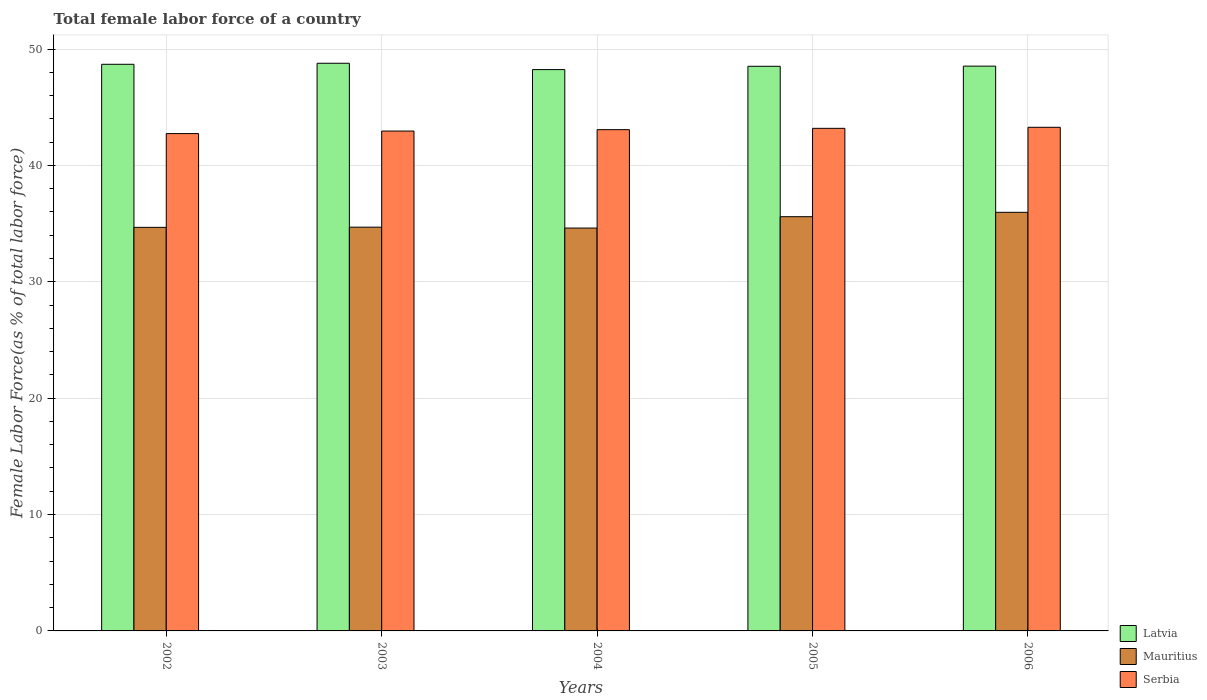How many groups of bars are there?
Make the answer very short. 5. Are the number of bars per tick equal to the number of legend labels?
Your response must be concise. Yes. Are the number of bars on each tick of the X-axis equal?
Make the answer very short. Yes. How many bars are there on the 5th tick from the left?
Give a very brief answer. 3. What is the label of the 3rd group of bars from the left?
Your answer should be very brief. 2004. What is the percentage of female labor force in Latvia in 2003?
Your answer should be compact. 48.78. Across all years, what is the maximum percentage of female labor force in Latvia?
Ensure brevity in your answer.  48.78. Across all years, what is the minimum percentage of female labor force in Latvia?
Offer a terse response. 48.23. In which year was the percentage of female labor force in Serbia maximum?
Make the answer very short. 2006. In which year was the percentage of female labor force in Serbia minimum?
Ensure brevity in your answer.  2002. What is the total percentage of female labor force in Mauritius in the graph?
Provide a short and direct response. 175.54. What is the difference between the percentage of female labor force in Serbia in 2003 and that in 2004?
Ensure brevity in your answer.  -0.12. What is the difference between the percentage of female labor force in Mauritius in 2005 and the percentage of female labor force in Serbia in 2006?
Provide a succinct answer. -7.68. What is the average percentage of female labor force in Mauritius per year?
Keep it short and to the point. 35.11. In the year 2002, what is the difference between the percentage of female labor force in Latvia and percentage of female labor force in Serbia?
Keep it short and to the point. 5.95. In how many years, is the percentage of female labor force in Latvia greater than 42 %?
Your answer should be very brief. 5. What is the ratio of the percentage of female labor force in Mauritius in 2003 to that in 2005?
Offer a very short reply. 0.97. Is the percentage of female labor force in Latvia in 2002 less than that in 2003?
Make the answer very short. Yes. What is the difference between the highest and the second highest percentage of female labor force in Mauritius?
Your response must be concise. 0.38. What is the difference between the highest and the lowest percentage of female labor force in Serbia?
Make the answer very short. 0.54. What does the 2nd bar from the left in 2005 represents?
Your response must be concise. Mauritius. What does the 2nd bar from the right in 2003 represents?
Make the answer very short. Mauritius. Are all the bars in the graph horizontal?
Provide a short and direct response. No. What is the difference between two consecutive major ticks on the Y-axis?
Your answer should be compact. 10. Does the graph contain any zero values?
Offer a terse response. No. How are the legend labels stacked?
Your response must be concise. Vertical. What is the title of the graph?
Ensure brevity in your answer.  Total female labor force of a country. Does "Romania" appear as one of the legend labels in the graph?
Ensure brevity in your answer.  No. What is the label or title of the X-axis?
Your answer should be very brief. Years. What is the label or title of the Y-axis?
Your response must be concise. Female Labor Force(as % of total labor force). What is the Female Labor Force(as % of total labor force) in Latvia in 2002?
Give a very brief answer. 48.69. What is the Female Labor Force(as % of total labor force) in Mauritius in 2002?
Give a very brief answer. 34.68. What is the Female Labor Force(as % of total labor force) of Serbia in 2002?
Ensure brevity in your answer.  42.73. What is the Female Labor Force(as % of total labor force) in Latvia in 2003?
Your answer should be very brief. 48.78. What is the Female Labor Force(as % of total labor force) of Mauritius in 2003?
Make the answer very short. 34.69. What is the Female Labor Force(as % of total labor force) of Serbia in 2003?
Your answer should be compact. 42.95. What is the Female Labor Force(as % of total labor force) in Latvia in 2004?
Keep it short and to the point. 48.23. What is the Female Labor Force(as % of total labor force) of Mauritius in 2004?
Make the answer very short. 34.62. What is the Female Labor Force(as % of total labor force) in Serbia in 2004?
Your answer should be very brief. 43.07. What is the Female Labor Force(as % of total labor force) of Latvia in 2005?
Your answer should be compact. 48.52. What is the Female Labor Force(as % of total labor force) of Mauritius in 2005?
Offer a very short reply. 35.59. What is the Female Labor Force(as % of total labor force) in Serbia in 2005?
Your answer should be very brief. 43.18. What is the Female Labor Force(as % of total labor force) in Latvia in 2006?
Your response must be concise. 48.53. What is the Female Labor Force(as % of total labor force) of Mauritius in 2006?
Ensure brevity in your answer.  35.97. What is the Female Labor Force(as % of total labor force) in Serbia in 2006?
Ensure brevity in your answer.  43.27. Across all years, what is the maximum Female Labor Force(as % of total labor force) in Latvia?
Ensure brevity in your answer.  48.78. Across all years, what is the maximum Female Labor Force(as % of total labor force) in Mauritius?
Provide a short and direct response. 35.97. Across all years, what is the maximum Female Labor Force(as % of total labor force) of Serbia?
Your answer should be very brief. 43.27. Across all years, what is the minimum Female Labor Force(as % of total labor force) of Latvia?
Your answer should be compact. 48.23. Across all years, what is the minimum Female Labor Force(as % of total labor force) of Mauritius?
Make the answer very short. 34.62. Across all years, what is the minimum Female Labor Force(as % of total labor force) in Serbia?
Give a very brief answer. 42.73. What is the total Female Labor Force(as % of total labor force) of Latvia in the graph?
Offer a terse response. 242.74. What is the total Female Labor Force(as % of total labor force) in Mauritius in the graph?
Your response must be concise. 175.54. What is the total Female Labor Force(as % of total labor force) of Serbia in the graph?
Your answer should be very brief. 215.21. What is the difference between the Female Labor Force(as % of total labor force) in Latvia in 2002 and that in 2003?
Offer a very short reply. -0.09. What is the difference between the Female Labor Force(as % of total labor force) in Mauritius in 2002 and that in 2003?
Give a very brief answer. -0.02. What is the difference between the Female Labor Force(as % of total labor force) in Serbia in 2002 and that in 2003?
Offer a very short reply. -0.22. What is the difference between the Female Labor Force(as % of total labor force) of Latvia in 2002 and that in 2004?
Provide a succinct answer. 0.46. What is the difference between the Female Labor Force(as % of total labor force) of Mauritius in 2002 and that in 2004?
Offer a terse response. 0.06. What is the difference between the Female Labor Force(as % of total labor force) of Serbia in 2002 and that in 2004?
Offer a terse response. -0.34. What is the difference between the Female Labor Force(as % of total labor force) of Latvia in 2002 and that in 2005?
Your answer should be compact. 0.17. What is the difference between the Female Labor Force(as % of total labor force) of Mauritius in 2002 and that in 2005?
Make the answer very short. -0.92. What is the difference between the Female Labor Force(as % of total labor force) in Serbia in 2002 and that in 2005?
Ensure brevity in your answer.  -0.45. What is the difference between the Female Labor Force(as % of total labor force) in Latvia in 2002 and that in 2006?
Offer a very short reply. 0.16. What is the difference between the Female Labor Force(as % of total labor force) of Mauritius in 2002 and that in 2006?
Give a very brief answer. -1.29. What is the difference between the Female Labor Force(as % of total labor force) of Serbia in 2002 and that in 2006?
Your response must be concise. -0.54. What is the difference between the Female Labor Force(as % of total labor force) in Latvia in 2003 and that in 2004?
Your answer should be compact. 0.55. What is the difference between the Female Labor Force(as % of total labor force) in Mauritius in 2003 and that in 2004?
Give a very brief answer. 0.08. What is the difference between the Female Labor Force(as % of total labor force) of Serbia in 2003 and that in 2004?
Provide a short and direct response. -0.12. What is the difference between the Female Labor Force(as % of total labor force) in Latvia in 2003 and that in 2005?
Provide a succinct answer. 0.26. What is the difference between the Female Labor Force(as % of total labor force) of Mauritius in 2003 and that in 2005?
Offer a very short reply. -0.9. What is the difference between the Female Labor Force(as % of total labor force) in Serbia in 2003 and that in 2005?
Offer a very short reply. -0.23. What is the difference between the Female Labor Force(as % of total labor force) in Latvia in 2003 and that in 2006?
Your answer should be very brief. 0.25. What is the difference between the Female Labor Force(as % of total labor force) in Mauritius in 2003 and that in 2006?
Your response must be concise. -1.28. What is the difference between the Female Labor Force(as % of total labor force) in Serbia in 2003 and that in 2006?
Give a very brief answer. -0.32. What is the difference between the Female Labor Force(as % of total labor force) of Latvia in 2004 and that in 2005?
Provide a short and direct response. -0.28. What is the difference between the Female Labor Force(as % of total labor force) in Mauritius in 2004 and that in 2005?
Your answer should be compact. -0.98. What is the difference between the Female Labor Force(as % of total labor force) in Serbia in 2004 and that in 2005?
Your answer should be very brief. -0.11. What is the difference between the Female Labor Force(as % of total labor force) of Latvia in 2004 and that in 2006?
Give a very brief answer. -0.3. What is the difference between the Female Labor Force(as % of total labor force) of Mauritius in 2004 and that in 2006?
Your answer should be very brief. -1.35. What is the difference between the Female Labor Force(as % of total labor force) of Serbia in 2004 and that in 2006?
Offer a terse response. -0.2. What is the difference between the Female Labor Force(as % of total labor force) of Latvia in 2005 and that in 2006?
Offer a very short reply. -0.01. What is the difference between the Female Labor Force(as % of total labor force) of Mauritius in 2005 and that in 2006?
Offer a terse response. -0.38. What is the difference between the Female Labor Force(as % of total labor force) of Serbia in 2005 and that in 2006?
Provide a succinct answer. -0.09. What is the difference between the Female Labor Force(as % of total labor force) in Latvia in 2002 and the Female Labor Force(as % of total labor force) in Mauritius in 2003?
Offer a terse response. 14. What is the difference between the Female Labor Force(as % of total labor force) of Latvia in 2002 and the Female Labor Force(as % of total labor force) of Serbia in 2003?
Offer a very short reply. 5.74. What is the difference between the Female Labor Force(as % of total labor force) in Mauritius in 2002 and the Female Labor Force(as % of total labor force) in Serbia in 2003?
Ensure brevity in your answer.  -8.28. What is the difference between the Female Labor Force(as % of total labor force) in Latvia in 2002 and the Female Labor Force(as % of total labor force) in Mauritius in 2004?
Provide a short and direct response. 14.07. What is the difference between the Female Labor Force(as % of total labor force) in Latvia in 2002 and the Female Labor Force(as % of total labor force) in Serbia in 2004?
Offer a terse response. 5.62. What is the difference between the Female Labor Force(as % of total labor force) of Mauritius in 2002 and the Female Labor Force(as % of total labor force) of Serbia in 2004?
Your answer should be compact. -8.39. What is the difference between the Female Labor Force(as % of total labor force) of Latvia in 2002 and the Female Labor Force(as % of total labor force) of Mauritius in 2005?
Offer a very short reply. 13.1. What is the difference between the Female Labor Force(as % of total labor force) in Latvia in 2002 and the Female Labor Force(as % of total labor force) in Serbia in 2005?
Your answer should be very brief. 5.5. What is the difference between the Female Labor Force(as % of total labor force) in Mauritius in 2002 and the Female Labor Force(as % of total labor force) in Serbia in 2005?
Your answer should be very brief. -8.51. What is the difference between the Female Labor Force(as % of total labor force) in Latvia in 2002 and the Female Labor Force(as % of total labor force) in Mauritius in 2006?
Provide a short and direct response. 12.72. What is the difference between the Female Labor Force(as % of total labor force) in Latvia in 2002 and the Female Labor Force(as % of total labor force) in Serbia in 2006?
Keep it short and to the point. 5.41. What is the difference between the Female Labor Force(as % of total labor force) in Mauritius in 2002 and the Female Labor Force(as % of total labor force) in Serbia in 2006?
Ensure brevity in your answer.  -8.6. What is the difference between the Female Labor Force(as % of total labor force) in Latvia in 2003 and the Female Labor Force(as % of total labor force) in Mauritius in 2004?
Offer a terse response. 14.16. What is the difference between the Female Labor Force(as % of total labor force) in Latvia in 2003 and the Female Labor Force(as % of total labor force) in Serbia in 2004?
Keep it short and to the point. 5.71. What is the difference between the Female Labor Force(as % of total labor force) of Mauritius in 2003 and the Female Labor Force(as % of total labor force) of Serbia in 2004?
Offer a terse response. -8.38. What is the difference between the Female Labor Force(as % of total labor force) in Latvia in 2003 and the Female Labor Force(as % of total labor force) in Mauritius in 2005?
Make the answer very short. 13.18. What is the difference between the Female Labor Force(as % of total labor force) of Latvia in 2003 and the Female Labor Force(as % of total labor force) of Serbia in 2005?
Provide a succinct answer. 5.59. What is the difference between the Female Labor Force(as % of total labor force) of Mauritius in 2003 and the Female Labor Force(as % of total labor force) of Serbia in 2005?
Give a very brief answer. -8.49. What is the difference between the Female Labor Force(as % of total labor force) of Latvia in 2003 and the Female Labor Force(as % of total labor force) of Mauritius in 2006?
Provide a succinct answer. 12.81. What is the difference between the Female Labor Force(as % of total labor force) of Latvia in 2003 and the Female Labor Force(as % of total labor force) of Serbia in 2006?
Provide a short and direct response. 5.5. What is the difference between the Female Labor Force(as % of total labor force) in Mauritius in 2003 and the Female Labor Force(as % of total labor force) in Serbia in 2006?
Provide a short and direct response. -8.58. What is the difference between the Female Labor Force(as % of total labor force) of Latvia in 2004 and the Female Labor Force(as % of total labor force) of Mauritius in 2005?
Ensure brevity in your answer.  12.64. What is the difference between the Female Labor Force(as % of total labor force) of Latvia in 2004 and the Female Labor Force(as % of total labor force) of Serbia in 2005?
Offer a very short reply. 5.05. What is the difference between the Female Labor Force(as % of total labor force) of Mauritius in 2004 and the Female Labor Force(as % of total labor force) of Serbia in 2005?
Offer a terse response. -8.57. What is the difference between the Female Labor Force(as % of total labor force) of Latvia in 2004 and the Female Labor Force(as % of total labor force) of Mauritius in 2006?
Provide a short and direct response. 12.26. What is the difference between the Female Labor Force(as % of total labor force) in Latvia in 2004 and the Female Labor Force(as % of total labor force) in Serbia in 2006?
Make the answer very short. 4.96. What is the difference between the Female Labor Force(as % of total labor force) in Mauritius in 2004 and the Female Labor Force(as % of total labor force) in Serbia in 2006?
Ensure brevity in your answer.  -8.66. What is the difference between the Female Labor Force(as % of total labor force) of Latvia in 2005 and the Female Labor Force(as % of total labor force) of Mauritius in 2006?
Your response must be concise. 12.55. What is the difference between the Female Labor Force(as % of total labor force) of Latvia in 2005 and the Female Labor Force(as % of total labor force) of Serbia in 2006?
Keep it short and to the point. 5.24. What is the difference between the Female Labor Force(as % of total labor force) in Mauritius in 2005 and the Female Labor Force(as % of total labor force) in Serbia in 2006?
Your answer should be compact. -7.68. What is the average Female Labor Force(as % of total labor force) in Latvia per year?
Give a very brief answer. 48.55. What is the average Female Labor Force(as % of total labor force) in Mauritius per year?
Your answer should be compact. 35.11. What is the average Female Labor Force(as % of total labor force) in Serbia per year?
Ensure brevity in your answer.  43.04. In the year 2002, what is the difference between the Female Labor Force(as % of total labor force) in Latvia and Female Labor Force(as % of total labor force) in Mauritius?
Make the answer very short. 14.01. In the year 2002, what is the difference between the Female Labor Force(as % of total labor force) in Latvia and Female Labor Force(as % of total labor force) in Serbia?
Your response must be concise. 5.95. In the year 2002, what is the difference between the Female Labor Force(as % of total labor force) of Mauritius and Female Labor Force(as % of total labor force) of Serbia?
Make the answer very short. -8.06. In the year 2003, what is the difference between the Female Labor Force(as % of total labor force) in Latvia and Female Labor Force(as % of total labor force) in Mauritius?
Offer a very short reply. 14.08. In the year 2003, what is the difference between the Female Labor Force(as % of total labor force) in Latvia and Female Labor Force(as % of total labor force) in Serbia?
Keep it short and to the point. 5.83. In the year 2003, what is the difference between the Female Labor Force(as % of total labor force) in Mauritius and Female Labor Force(as % of total labor force) in Serbia?
Your answer should be very brief. -8.26. In the year 2004, what is the difference between the Female Labor Force(as % of total labor force) in Latvia and Female Labor Force(as % of total labor force) in Mauritius?
Make the answer very short. 13.61. In the year 2004, what is the difference between the Female Labor Force(as % of total labor force) in Latvia and Female Labor Force(as % of total labor force) in Serbia?
Your response must be concise. 5.16. In the year 2004, what is the difference between the Female Labor Force(as % of total labor force) in Mauritius and Female Labor Force(as % of total labor force) in Serbia?
Your response must be concise. -8.45. In the year 2005, what is the difference between the Female Labor Force(as % of total labor force) of Latvia and Female Labor Force(as % of total labor force) of Mauritius?
Your answer should be very brief. 12.92. In the year 2005, what is the difference between the Female Labor Force(as % of total labor force) of Latvia and Female Labor Force(as % of total labor force) of Serbia?
Offer a very short reply. 5.33. In the year 2005, what is the difference between the Female Labor Force(as % of total labor force) of Mauritius and Female Labor Force(as % of total labor force) of Serbia?
Offer a very short reply. -7.59. In the year 2006, what is the difference between the Female Labor Force(as % of total labor force) in Latvia and Female Labor Force(as % of total labor force) in Mauritius?
Offer a terse response. 12.56. In the year 2006, what is the difference between the Female Labor Force(as % of total labor force) in Latvia and Female Labor Force(as % of total labor force) in Serbia?
Make the answer very short. 5.25. In the year 2006, what is the difference between the Female Labor Force(as % of total labor force) in Mauritius and Female Labor Force(as % of total labor force) in Serbia?
Provide a short and direct response. -7.31. What is the ratio of the Female Labor Force(as % of total labor force) of Latvia in 2002 to that in 2003?
Give a very brief answer. 1. What is the ratio of the Female Labor Force(as % of total labor force) in Latvia in 2002 to that in 2004?
Your answer should be very brief. 1.01. What is the ratio of the Female Labor Force(as % of total labor force) in Mauritius in 2002 to that in 2004?
Offer a terse response. 1. What is the ratio of the Female Labor Force(as % of total labor force) of Serbia in 2002 to that in 2004?
Provide a succinct answer. 0.99. What is the ratio of the Female Labor Force(as % of total labor force) in Latvia in 2002 to that in 2005?
Give a very brief answer. 1. What is the ratio of the Female Labor Force(as % of total labor force) of Mauritius in 2002 to that in 2005?
Keep it short and to the point. 0.97. What is the ratio of the Female Labor Force(as % of total labor force) of Serbia in 2002 to that in 2005?
Provide a succinct answer. 0.99. What is the ratio of the Female Labor Force(as % of total labor force) in Latvia in 2002 to that in 2006?
Offer a terse response. 1. What is the ratio of the Female Labor Force(as % of total labor force) of Mauritius in 2002 to that in 2006?
Provide a short and direct response. 0.96. What is the ratio of the Female Labor Force(as % of total labor force) in Serbia in 2002 to that in 2006?
Your answer should be very brief. 0.99. What is the ratio of the Female Labor Force(as % of total labor force) in Latvia in 2003 to that in 2004?
Make the answer very short. 1.01. What is the ratio of the Female Labor Force(as % of total labor force) in Serbia in 2003 to that in 2004?
Offer a terse response. 1. What is the ratio of the Female Labor Force(as % of total labor force) of Latvia in 2003 to that in 2005?
Keep it short and to the point. 1.01. What is the ratio of the Female Labor Force(as % of total labor force) of Mauritius in 2003 to that in 2005?
Offer a very short reply. 0.97. What is the ratio of the Female Labor Force(as % of total labor force) of Serbia in 2003 to that in 2005?
Provide a succinct answer. 0.99. What is the ratio of the Female Labor Force(as % of total labor force) in Mauritius in 2003 to that in 2006?
Your response must be concise. 0.96. What is the ratio of the Female Labor Force(as % of total labor force) of Mauritius in 2004 to that in 2005?
Your answer should be compact. 0.97. What is the ratio of the Female Labor Force(as % of total labor force) of Mauritius in 2004 to that in 2006?
Your response must be concise. 0.96. What is the ratio of the Female Labor Force(as % of total labor force) in Mauritius in 2005 to that in 2006?
Offer a very short reply. 0.99. What is the ratio of the Female Labor Force(as % of total labor force) in Serbia in 2005 to that in 2006?
Offer a very short reply. 1. What is the difference between the highest and the second highest Female Labor Force(as % of total labor force) of Latvia?
Ensure brevity in your answer.  0.09. What is the difference between the highest and the second highest Female Labor Force(as % of total labor force) in Mauritius?
Your answer should be compact. 0.38. What is the difference between the highest and the second highest Female Labor Force(as % of total labor force) of Serbia?
Your answer should be compact. 0.09. What is the difference between the highest and the lowest Female Labor Force(as % of total labor force) of Latvia?
Give a very brief answer. 0.55. What is the difference between the highest and the lowest Female Labor Force(as % of total labor force) of Mauritius?
Provide a short and direct response. 1.35. What is the difference between the highest and the lowest Female Labor Force(as % of total labor force) of Serbia?
Keep it short and to the point. 0.54. 